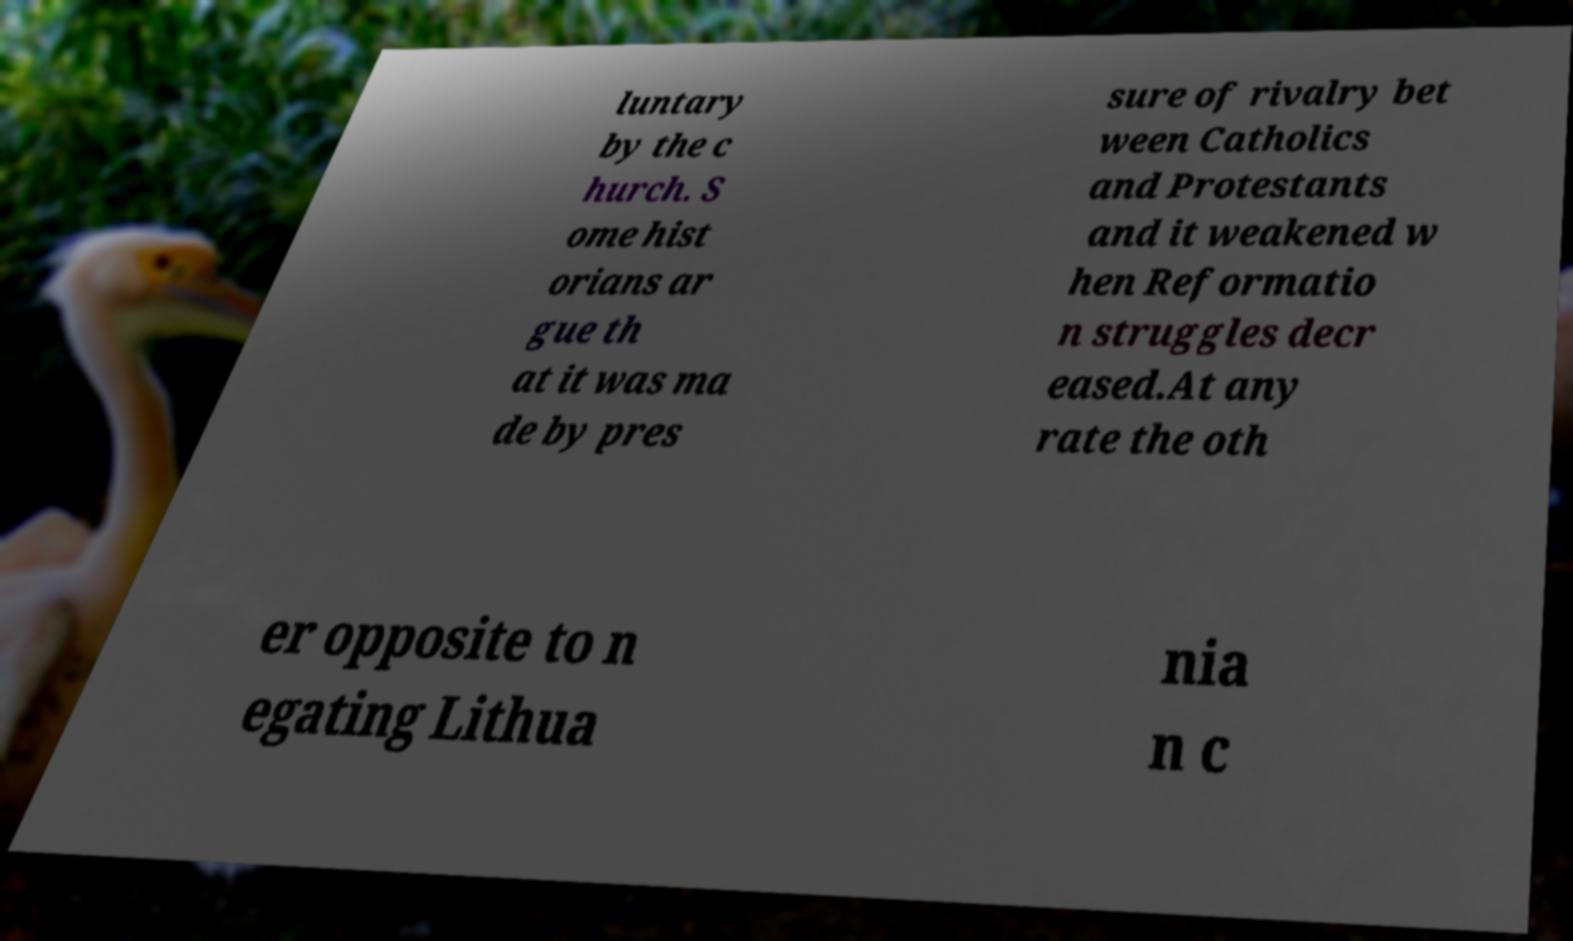Please identify and transcribe the text found in this image. luntary by the c hurch. S ome hist orians ar gue th at it was ma de by pres sure of rivalry bet ween Catholics and Protestants and it weakened w hen Reformatio n struggles decr eased.At any rate the oth er opposite to n egating Lithua nia n c 